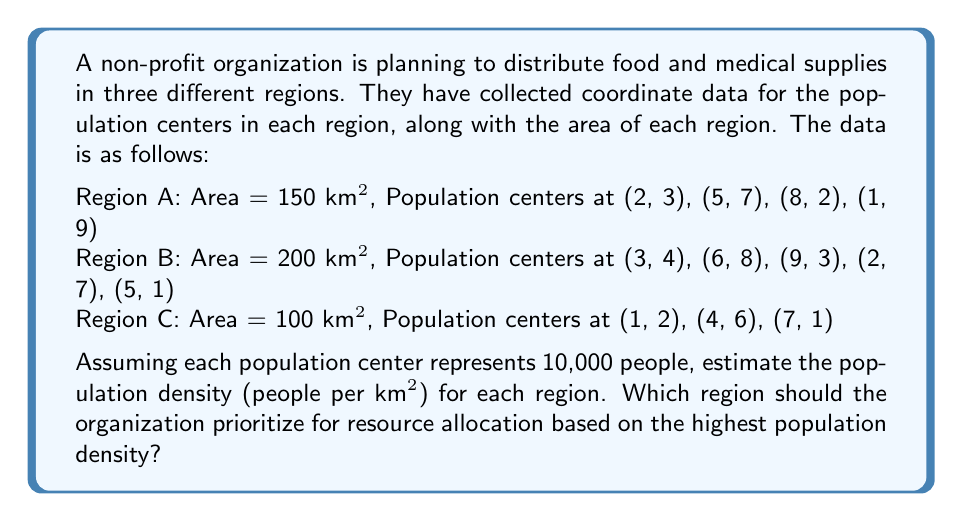Can you solve this math problem? To solve this problem, we need to follow these steps:

1. Calculate the total population for each region:
   - Count the number of population centers in each region
   - Multiply the number of centers by 10,000 (given that each center represents 10,000 people)

2. Calculate the population density for each region:
   - Use the formula: Population Density = Total Population / Area

3. Compare the population densities to determine which region has the highest density

Let's go through each step:

1. Calculating total population:
   Region A: 4 centers × 10,000 = 40,000 people
   Region B: 5 centers × 10,000 = 50,000 people
   Region C: 3 centers × 10,000 = 30,000 people

2. Calculating population density:
   Region A: $\text{Density}_A = \frac{40,000}{150} = 266.67$ people/km²
   Region B: $\text{Density}_B = \frac{50,000}{200} = 250$ people/km²
   Region C: $\text{Density}_C = \frac{30,000}{100} = 300$ people/km²

3. Comparing population densities:
   Region C has the highest population density at 300 people/km², followed by Region A at 266.67 people/km², and then Region B at 250 people/km².

Therefore, based on population density, the organization should prioritize Region C for resource allocation.
Answer: The population densities are:
Region A: 266.67 people/km²
Region B: 250 people/km²
Region C: 300 people/km²

The organization should prioritize Region C for resource allocation based on the highest population density. 